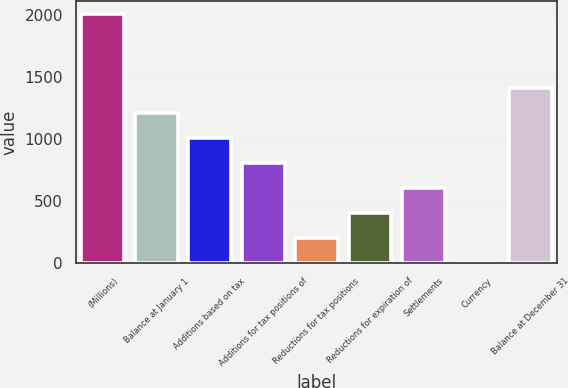Convert chart. <chart><loc_0><loc_0><loc_500><loc_500><bar_chart><fcel>(Millions)<fcel>Balance at January 1<fcel>Additions based on tax<fcel>Additions for tax positions of<fcel>Reductions for tax positions<fcel>Reductions for expiration of<fcel>Settlements<fcel>Currency<fcel>Balance at December 31<nl><fcel>2009<fcel>1207.4<fcel>1007<fcel>806.6<fcel>205.4<fcel>405.8<fcel>606.2<fcel>5<fcel>1407.8<nl></chart> 